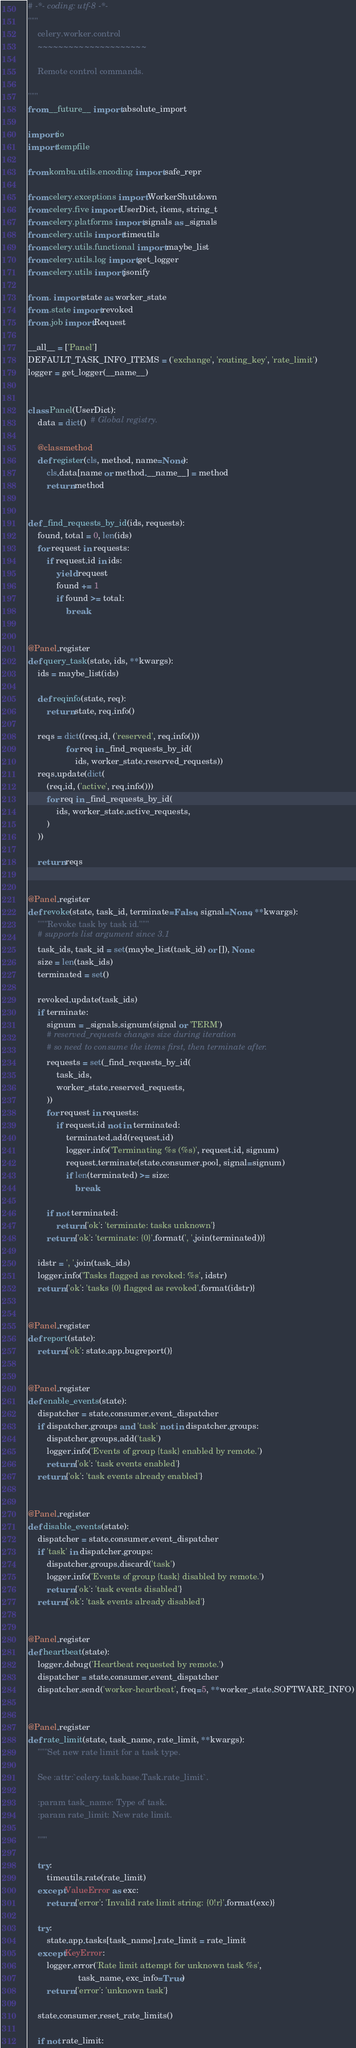<code> <loc_0><loc_0><loc_500><loc_500><_Python_># -*- coding: utf-8 -*-
"""
    celery.worker.control
    ~~~~~~~~~~~~~~~~~~~~~

    Remote control commands.

"""
from __future__ import absolute_import

import io
import tempfile

from kombu.utils.encoding import safe_repr

from celery.exceptions import WorkerShutdown
from celery.five import UserDict, items, string_t
from celery.platforms import signals as _signals
from celery.utils import timeutils
from celery.utils.functional import maybe_list
from celery.utils.log import get_logger
from celery.utils import jsonify

from . import state as worker_state
from .state import revoked
from .job import Request

__all__ = ['Panel']
DEFAULT_TASK_INFO_ITEMS = ('exchange', 'routing_key', 'rate_limit')
logger = get_logger(__name__)


class Panel(UserDict):
    data = dict()  # Global registry.

    @classmethod
    def register(cls, method, name=None):
        cls.data[name or method.__name__] = method
        return method


def _find_requests_by_id(ids, requests):
    found, total = 0, len(ids)
    for request in requests:
        if request.id in ids:
            yield request
            found += 1
            if found >= total:
                break


@Panel.register
def query_task(state, ids, **kwargs):
    ids = maybe_list(ids)

    def reqinfo(state, req):
        return state, req.info()

    reqs = dict((req.id, ('reserved', req.info()))
                for req in _find_requests_by_id(
                    ids, worker_state.reserved_requests))
    reqs.update(dict(
        (req.id, ('active', req.info()))
        for req in _find_requests_by_id(
            ids, worker_state.active_requests,
        )
    ))

    return reqs


@Panel.register
def revoke(state, task_id, terminate=False, signal=None, **kwargs):
    """Revoke task by task id."""
    # supports list argument since 3.1
    task_ids, task_id = set(maybe_list(task_id) or []), None
    size = len(task_ids)
    terminated = set()

    revoked.update(task_ids)
    if terminate:
        signum = _signals.signum(signal or 'TERM')
        # reserved_requests changes size during iteration
        # so need to consume the items first, then terminate after.
        requests = set(_find_requests_by_id(
            task_ids,
            worker_state.reserved_requests,
        ))
        for request in requests:
            if request.id not in terminated:
                terminated.add(request.id)
                logger.info('Terminating %s (%s)', request.id, signum)
                request.terminate(state.consumer.pool, signal=signum)
                if len(terminated) >= size:
                    break

        if not terminated:
            return {'ok': 'terminate: tasks unknown'}
        return {'ok': 'terminate: {0}'.format(', '.join(terminated))}

    idstr = ', '.join(task_ids)
    logger.info('Tasks flagged as revoked: %s', idstr)
    return {'ok': 'tasks {0} flagged as revoked'.format(idstr)}


@Panel.register
def report(state):
    return {'ok': state.app.bugreport()}


@Panel.register
def enable_events(state):
    dispatcher = state.consumer.event_dispatcher
    if dispatcher.groups and 'task' not in dispatcher.groups:
        dispatcher.groups.add('task')
        logger.info('Events of group {task} enabled by remote.')
        return {'ok': 'task events enabled'}
    return {'ok': 'task events already enabled'}


@Panel.register
def disable_events(state):
    dispatcher = state.consumer.event_dispatcher
    if 'task' in dispatcher.groups:
        dispatcher.groups.discard('task')
        logger.info('Events of group {task} disabled by remote.')
        return {'ok': 'task events disabled'}
    return {'ok': 'task events already disabled'}


@Panel.register
def heartbeat(state):
    logger.debug('Heartbeat requested by remote.')
    dispatcher = state.consumer.event_dispatcher
    dispatcher.send('worker-heartbeat', freq=5, **worker_state.SOFTWARE_INFO)


@Panel.register
def rate_limit(state, task_name, rate_limit, **kwargs):
    """Set new rate limit for a task type.

    See :attr:`celery.task.base.Task.rate_limit`.

    :param task_name: Type of task.
    :param rate_limit: New rate limit.

    """

    try:
        timeutils.rate(rate_limit)
    except ValueError as exc:
        return {'error': 'Invalid rate limit string: {0!r}'.format(exc)}

    try:
        state.app.tasks[task_name].rate_limit = rate_limit
    except KeyError:
        logger.error('Rate limit attempt for unknown task %s',
                     task_name, exc_info=True)
        return {'error': 'unknown task'}

    state.consumer.reset_rate_limits()

    if not rate_limit:</code> 